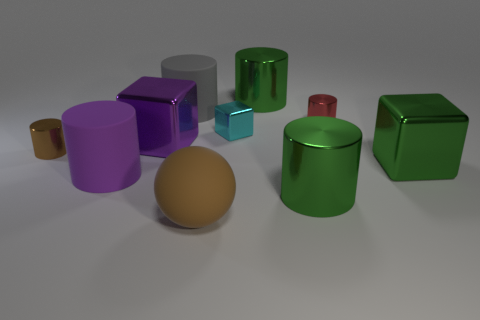Are there more brown shiny objects than tiny blue rubber blocks? Indeed, there are more brown shiny objects present than tiny blue rubber blocks. To be more precise, I'm observing one large, glossy brown sphere and another object that seems to reflect a similar sheen and hue, as opposed to just one small blue cube present in the scene. 